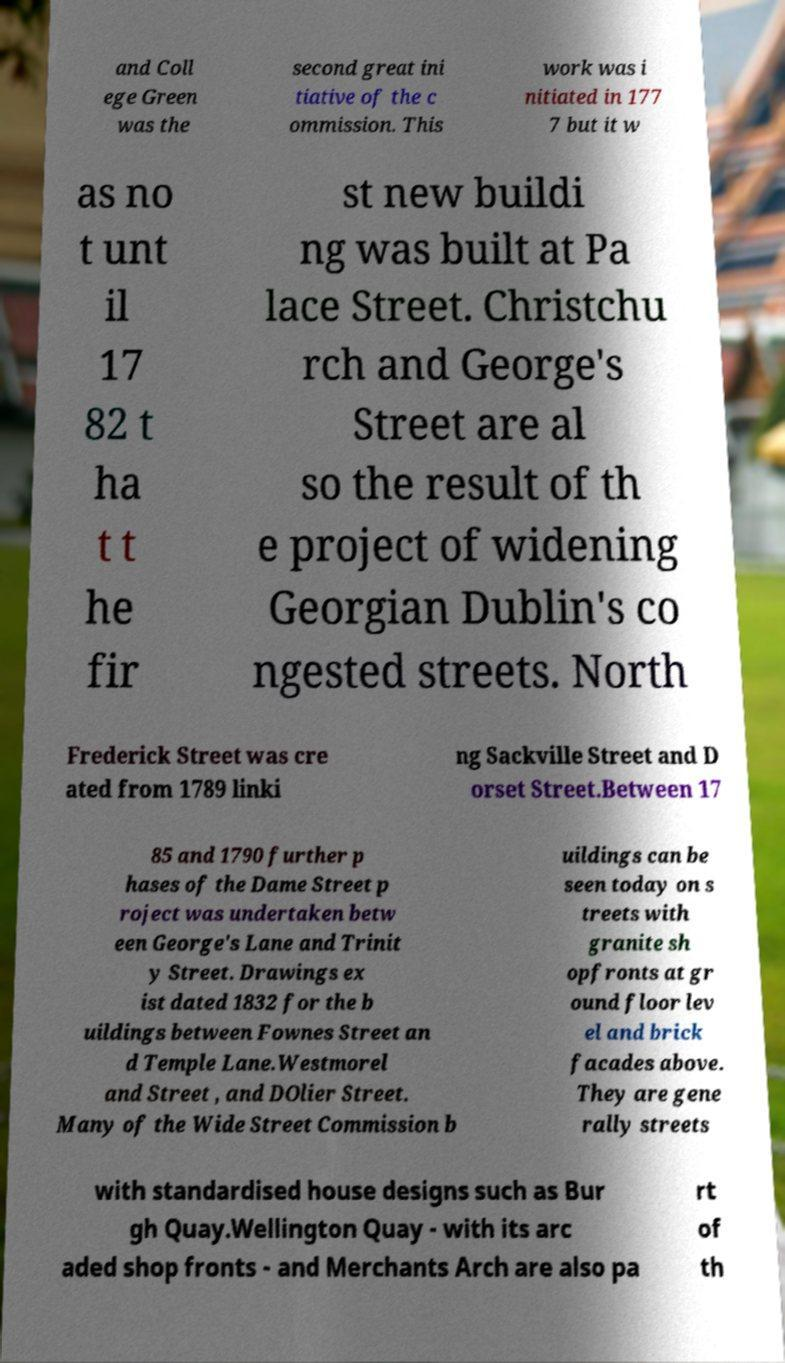Please identify and transcribe the text found in this image. and Coll ege Green was the second great ini tiative of the c ommission. This work was i nitiated in 177 7 but it w as no t unt il 17 82 t ha t t he fir st new buildi ng was built at Pa lace Street. Christchu rch and George's Street are al so the result of th e project of widening Georgian Dublin's co ngested streets. North Frederick Street was cre ated from 1789 linki ng Sackville Street and D orset Street.Between 17 85 and 1790 further p hases of the Dame Street p roject was undertaken betw een George's Lane and Trinit y Street. Drawings ex ist dated 1832 for the b uildings between Fownes Street an d Temple Lane.Westmorel and Street , and DOlier Street. Many of the Wide Street Commission b uildings can be seen today on s treets with granite sh opfronts at gr ound floor lev el and brick facades above. They are gene rally streets with standardised house designs such as Bur gh Quay.Wellington Quay - with its arc aded shop fronts - and Merchants Arch are also pa rt of th 